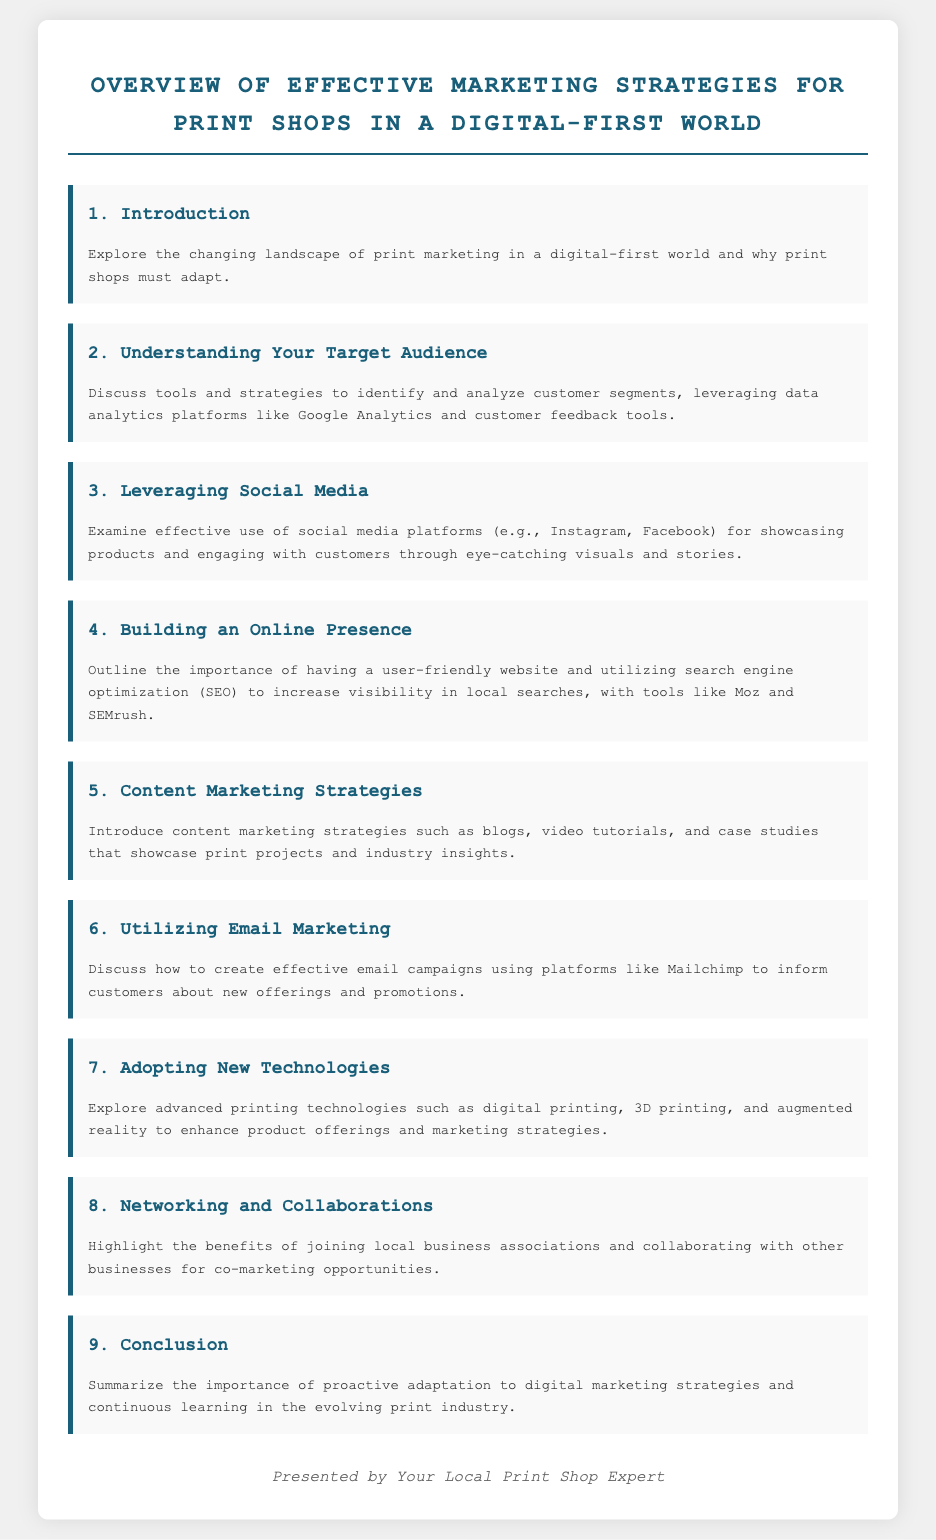What is the title of the document? The title is displayed prominently at the top of the document, summarizing its focus.
Answer: Overview of Effective Marketing Strategies for Print Shops in a Digital-First World How many agenda items are listed? The document outlines multiple sections, each representing a key topic in the agenda.
Answer: 9 What is the first topic discussed? The first item in the agenda introduces the overall theme of the document.
Answer: Introduction Which social media platforms are mentioned? The agenda discusses specific platforms that are effective for marketing, as highlighted in the respective section.
Answer: Instagram, Facebook What strategy is suggested for increasing local search visibility? The document outlines a specific strategy related to a digital tool that enhances market presence.
Answer: Search engine optimization (SEO) What technology is highlighted for adopting in the print industry? The document explores various advanced technologies that can be integrated into marketing efforts.
Answer: Digital printing Which email marketing platform is referenced? The document suggests a specific platform as a means for executing email campaigns effectively.
Answer: Mailchimp What is emphasized as necessary for a print shop's adaptation? The conclusion reflects on what print shops need to continuously engage with in their strategies.
Answer: Proactive adaptation to digital marketing strategies 